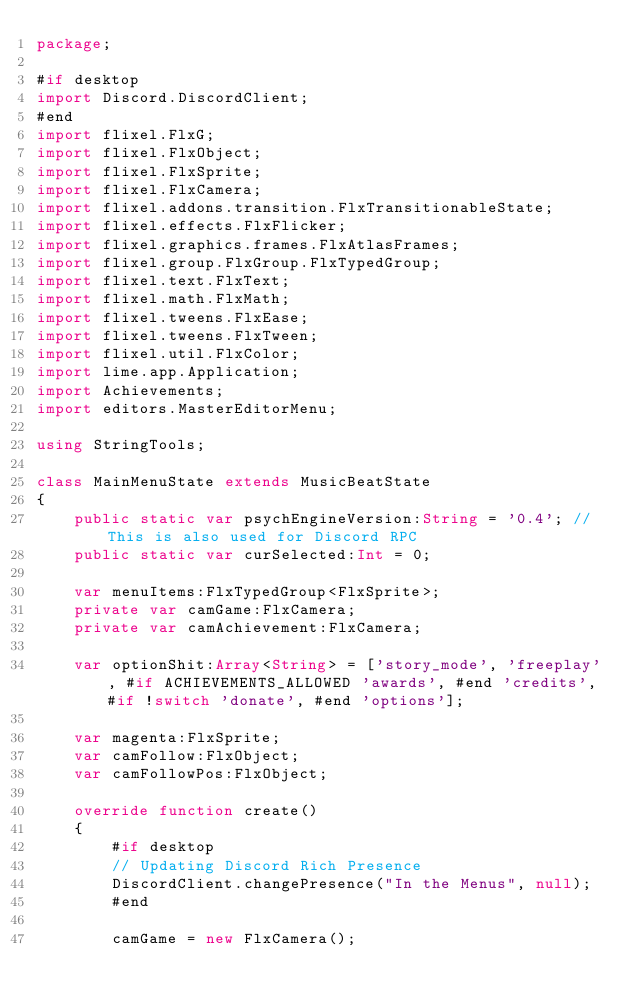<code> <loc_0><loc_0><loc_500><loc_500><_Haxe_>package;

#if desktop
import Discord.DiscordClient;
#end
import flixel.FlxG;
import flixel.FlxObject;
import flixel.FlxSprite;
import flixel.FlxCamera;
import flixel.addons.transition.FlxTransitionableState;
import flixel.effects.FlxFlicker;
import flixel.graphics.frames.FlxAtlasFrames;
import flixel.group.FlxGroup.FlxTypedGroup;
import flixel.text.FlxText;
import flixel.math.FlxMath;
import flixel.tweens.FlxEase;
import flixel.tweens.FlxTween;
import flixel.util.FlxColor;
import lime.app.Application;
import Achievements;
import editors.MasterEditorMenu;

using StringTools;

class MainMenuState extends MusicBeatState
{
	public static var psychEngineVersion:String = '0.4'; //This is also used for Discord RPC
	public static var curSelected:Int = 0;

	var menuItems:FlxTypedGroup<FlxSprite>;
	private var camGame:FlxCamera;
	private var camAchievement:FlxCamera;
	
	var optionShit:Array<String> = ['story_mode', 'freeplay', #if ACHIEVEMENTS_ALLOWED 'awards', #end 'credits', #if !switch 'donate', #end 'options'];

	var magenta:FlxSprite;
	var camFollow:FlxObject;
	var camFollowPos:FlxObject;

	override function create()
	{
		#if desktop
		// Updating Discord Rich Presence
		DiscordClient.changePresence("In the Menus", null);
		#end

		camGame = new FlxCamera();</code> 